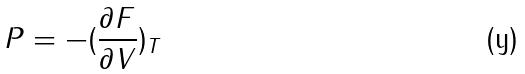Convert formula to latex. <formula><loc_0><loc_0><loc_500><loc_500>P = - ( \frac { \partial F } { \partial V } ) _ { T }</formula> 